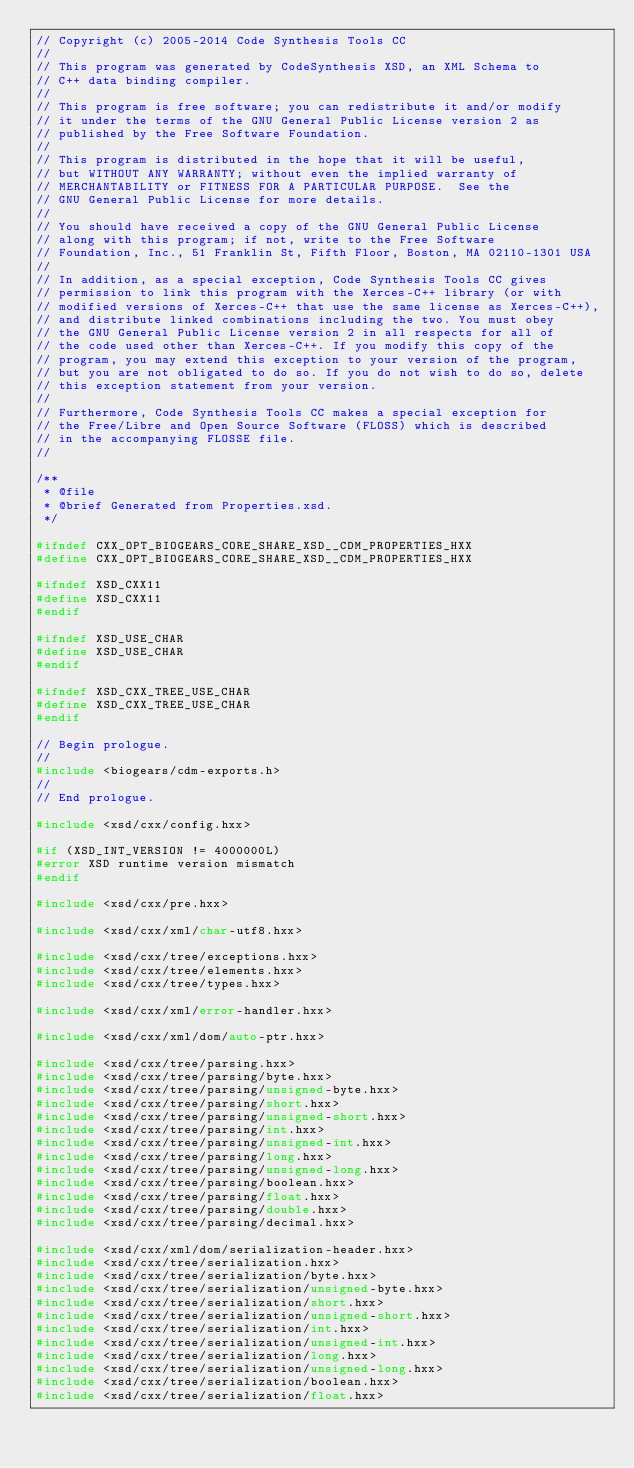<code> <loc_0><loc_0><loc_500><loc_500><_C++_>// Copyright (c) 2005-2014 Code Synthesis Tools CC
//
// This program was generated by CodeSynthesis XSD, an XML Schema to
// C++ data binding compiler.
//
// This program is free software; you can redistribute it and/or modify
// it under the terms of the GNU General Public License version 2 as
// published by the Free Software Foundation.
//
// This program is distributed in the hope that it will be useful,
// but WITHOUT ANY WARRANTY; without even the implied warranty of
// MERCHANTABILITY or FITNESS FOR A PARTICULAR PURPOSE.  See the
// GNU General Public License for more details.
//
// You should have received a copy of the GNU General Public License
// along with this program; if not, write to the Free Software
// Foundation, Inc., 51 Franklin St, Fifth Floor, Boston, MA 02110-1301 USA
//
// In addition, as a special exception, Code Synthesis Tools CC gives
// permission to link this program with the Xerces-C++ library (or with
// modified versions of Xerces-C++ that use the same license as Xerces-C++),
// and distribute linked combinations including the two. You must obey
// the GNU General Public License version 2 in all respects for all of
// the code used other than Xerces-C++. If you modify this copy of the
// program, you may extend this exception to your version of the program,
// but you are not obligated to do so. If you do not wish to do so, delete
// this exception statement from your version.
//
// Furthermore, Code Synthesis Tools CC makes a special exception for
// the Free/Libre and Open Source Software (FLOSS) which is described
// in the accompanying FLOSSE file.
//

/**
 * @file
 * @brief Generated from Properties.xsd.
 */

#ifndef CXX_OPT_BIOGEARS_CORE_SHARE_XSD__CDM_PROPERTIES_HXX
#define CXX_OPT_BIOGEARS_CORE_SHARE_XSD__CDM_PROPERTIES_HXX

#ifndef XSD_CXX11
#define XSD_CXX11
#endif

#ifndef XSD_USE_CHAR
#define XSD_USE_CHAR
#endif

#ifndef XSD_CXX_TREE_USE_CHAR
#define XSD_CXX_TREE_USE_CHAR
#endif

// Begin prologue.
//
#include <biogears/cdm-exports.h>
//
// End prologue.

#include <xsd/cxx/config.hxx>

#if (XSD_INT_VERSION != 4000000L)
#error XSD runtime version mismatch
#endif

#include <xsd/cxx/pre.hxx>

#include <xsd/cxx/xml/char-utf8.hxx>

#include <xsd/cxx/tree/exceptions.hxx>
#include <xsd/cxx/tree/elements.hxx>
#include <xsd/cxx/tree/types.hxx>

#include <xsd/cxx/xml/error-handler.hxx>

#include <xsd/cxx/xml/dom/auto-ptr.hxx>

#include <xsd/cxx/tree/parsing.hxx>
#include <xsd/cxx/tree/parsing/byte.hxx>
#include <xsd/cxx/tree/parsing/unsigned-byte.hxx>
#include <xsd/cxx/tree/parsing/short.hxx>
#include <xsd/cxx/tree/parsing/unsigned-short.hxx>
#include <xsd/cxx/tree/parsing/int.hxx>
#include <xsd/cxx/tree/parsing/unsigned-int.hxx>
#include <xsd/cxx/tree/parsing/long.hxx>
#include <xsd/cxx/tree/parsing/unsigned-long.hxx>
#include <xsd/cxx/tree/parsing/boolean.hxx>
#include <xsd/cxx/tree/parsing/float.hxx>
#include <xsd/cxx/tree/parsing/double.hxx>
#include <xsd/cxx/tree/parsing/decimal.hxx>

#include <xsd/cxx/xml/dom/serialization-header.hxx>
#include <xsd/cxx/tree/serialization.hxx>
#include <xsd/cxx/tree/serialization/byte.hxx>
#include <xsd/cxx/tree/serialization/unsigned-byte.hxx>
#include <xsd/cxx/tree/serialization/short.hxx>
#include <xsd/cxx/tree/serialization/unsigned-short.hxx>
#include <xsd/cxx/tree/serialization/int.hxx>
#include <xsd/cxx/tree/serialization/unsigned-int.hxx>
#include <xsd/cxx/tree/serialization/long.hxx>
#include <xsd/cxx/tree/serialization/unsigned-long.hxx>
#include <xsd/cxx/tree/serialization/boolean.hxx>
#include <xsd/cxx/tree/serialization/float.hxx></code> 